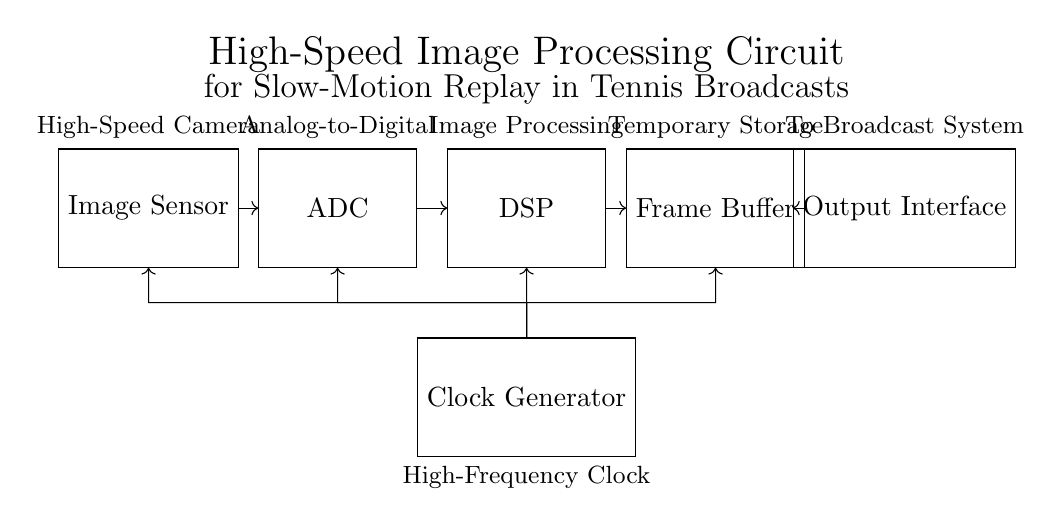What is the main purpose of this circuit? The main purpose of this circuit is to process high-speed images for slow-motion replay in tennis broadcasts, allowing viewers to see detailed action.
Answer: High-speed image processing What type of component is the ADC? The ADC, or Analog-to-Digital Converter, is a necessary component that converts the analog signals from the image sensor into digital format for further processing.
Answer: Converter How many main components are there in the circuit? There are five main components in the circuit: the Image Sensor, ADC, DSP, Frame Buffer, and Output Interface.
Answer: Five What role does the clock generator play in the circuit? The Clock Generator provides the high-frequency clock signals necessary to synchronize the components, enabling them to operate efficiently and in unison during image processing.
Answer: Synchronization Which component temporarily stores the processed images? The Frame Buffer is responsible for temporarily storing the processed images before they are sent out to the broadcast system.
Answer: Frame Buffer What is the output of this circuit intended for? The output of this circuit is intended for the broadcast system, allowing viewers to see the processed slow-motion replays during tennis matches.
Answer: Broadcast System What is the flow of data in the circuit starting from the image sensor? The data flow begins at the Image Sensor, proceeds to the ADC, then to the DSP for processing, moves to the Frame Buffer for temporary storage, and finally reaches the Output Interface for broadcasting.
Answer: Sensor to ADC to DSP to Buffer to Output 